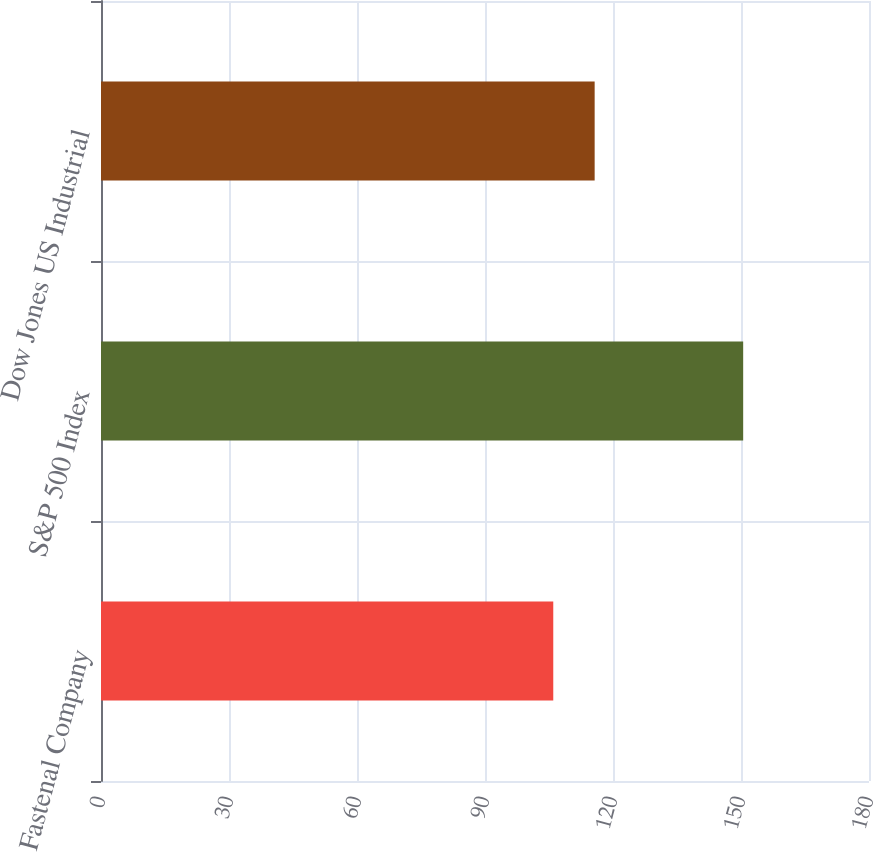Convert chart. <chart><loc_0><loc_0><loc_500><loc_500><bar_chart><fcel>Fastenal Company<fcel>S&P 500 Index<fcel>Dow Jones US Industrial<nl><fcel>106<fcel>150.51<fcel>115.7<nl></chart> 